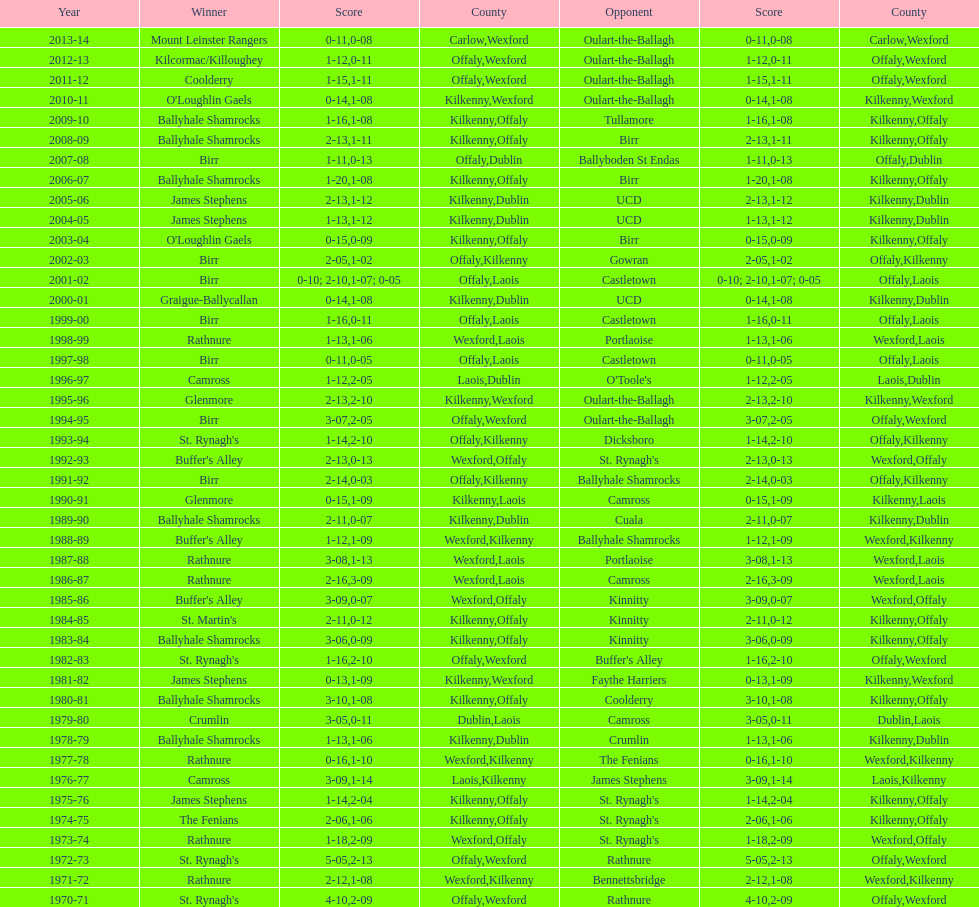Before birr's last win, which team emerged as the champion in the leinster senior club hurling championships? Ballyhale Shamrocks. 